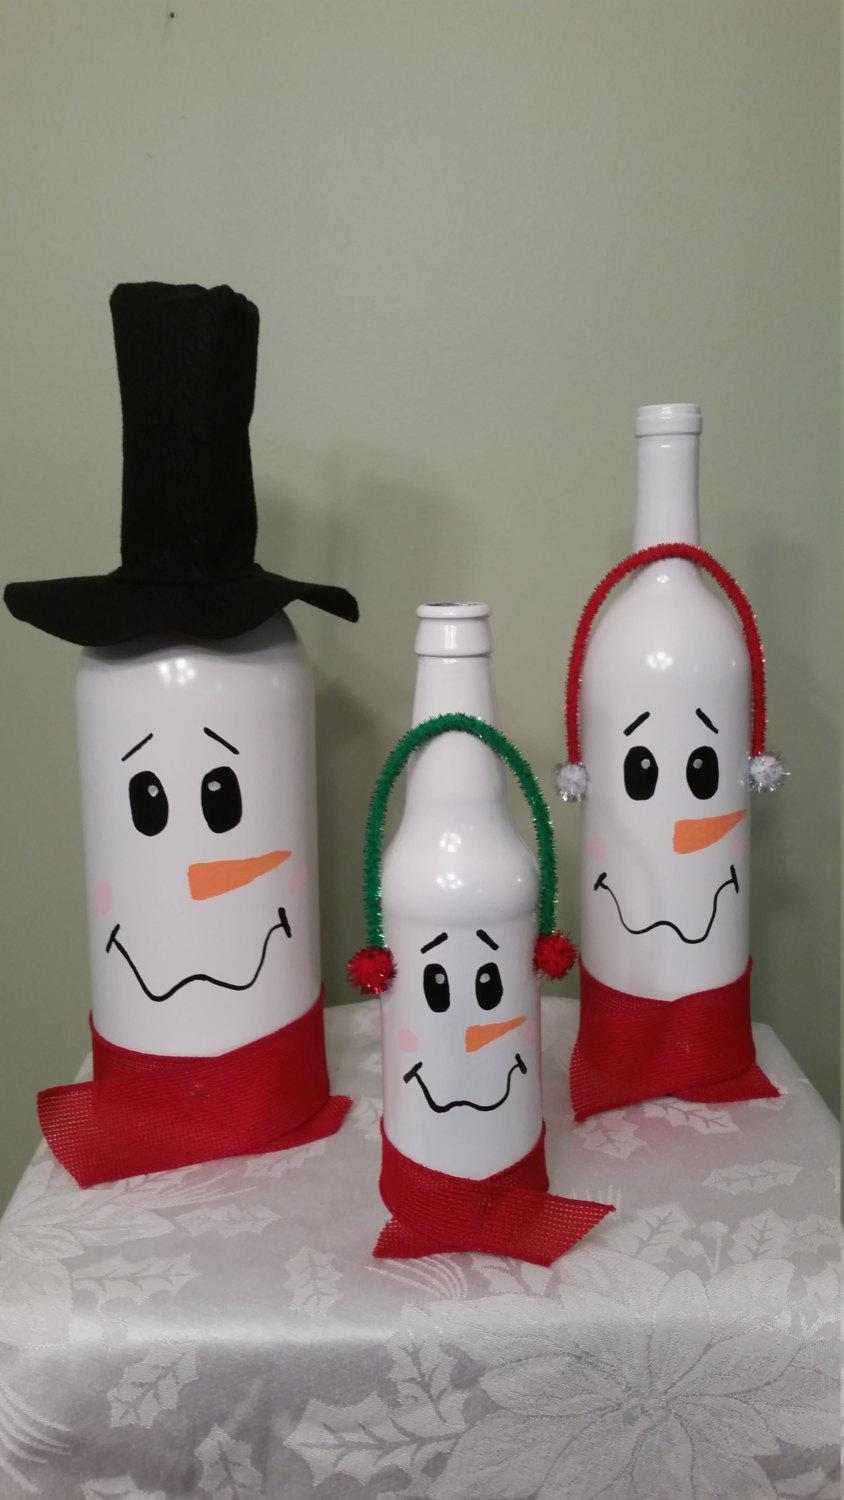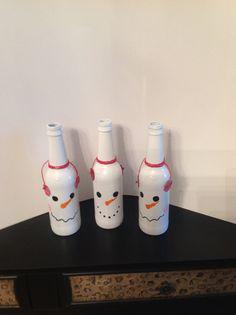The first image is the image on the left, the second image is the image on the right. For the images shown, is this caption "All of the bottles look like snowmen." true? Answer yes or no. Yes. 